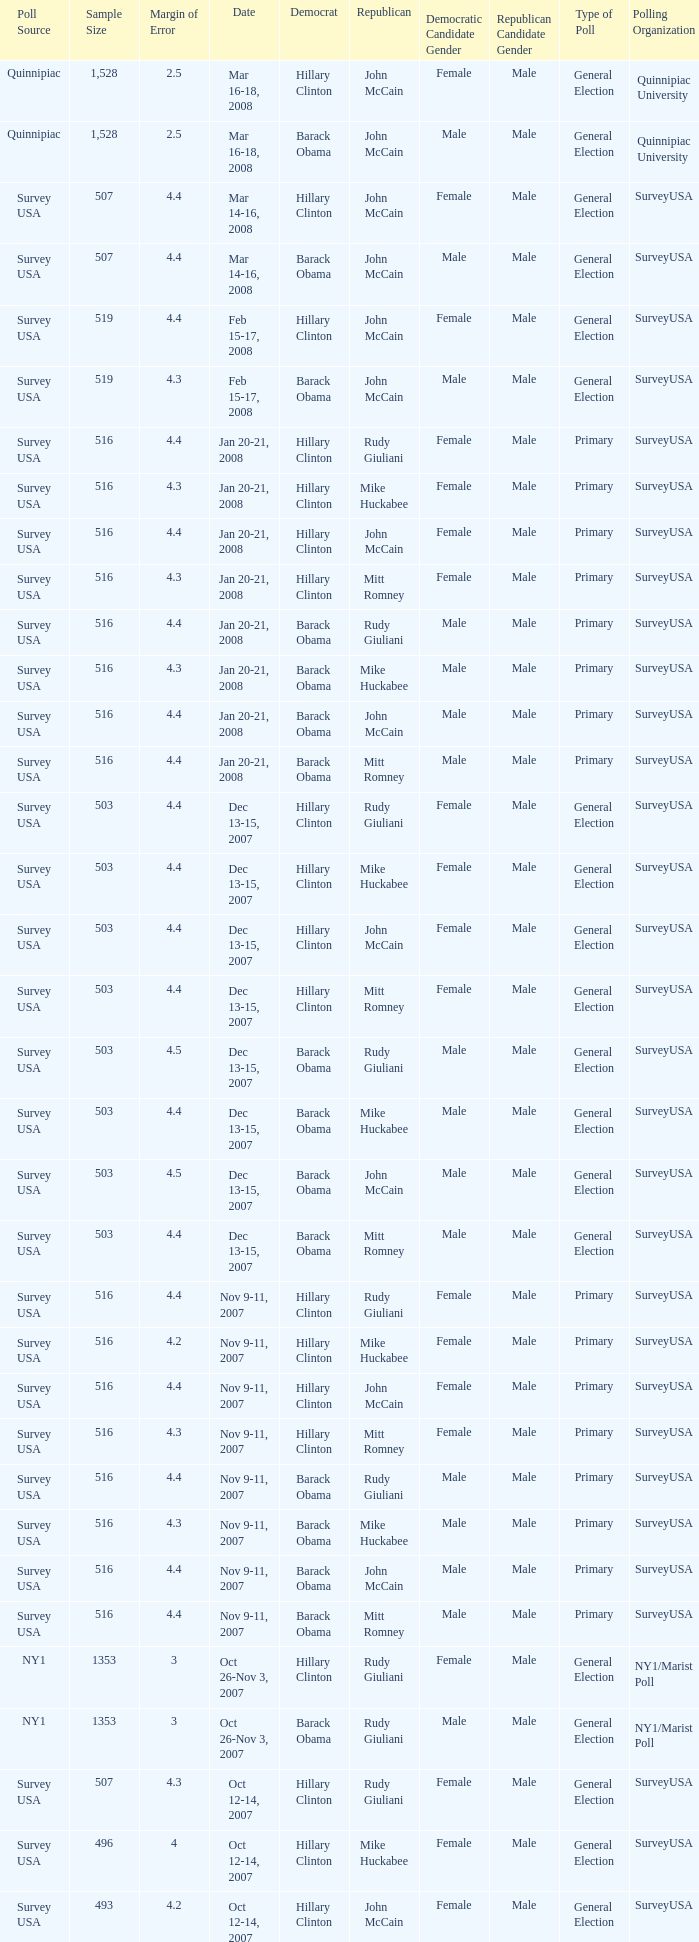Which Democrat was selected in the poll with a sample size smaller than 516 where the Republican chosen was Ron Paul? Hillary Clinton. 